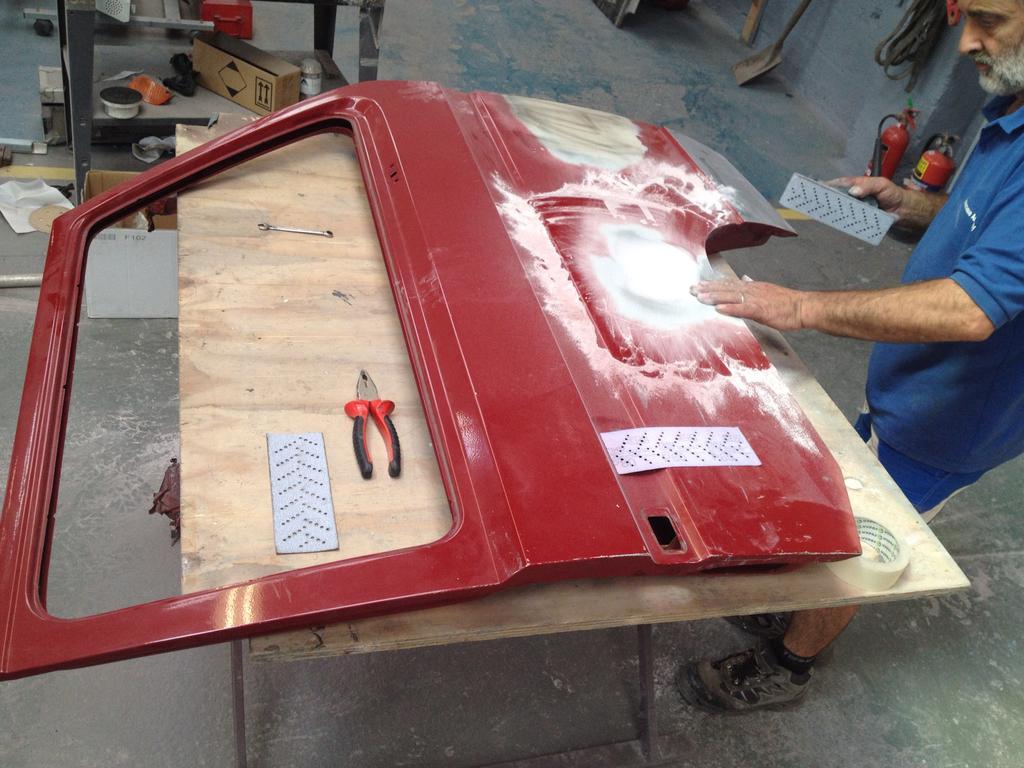Can you describe this image briefly? In the image we can see a man standing, wearing clothes and wearing shoes, and the man is holding an object in hand. This is a door of a vehicle, table, floor, box, hand tool and other objects. 